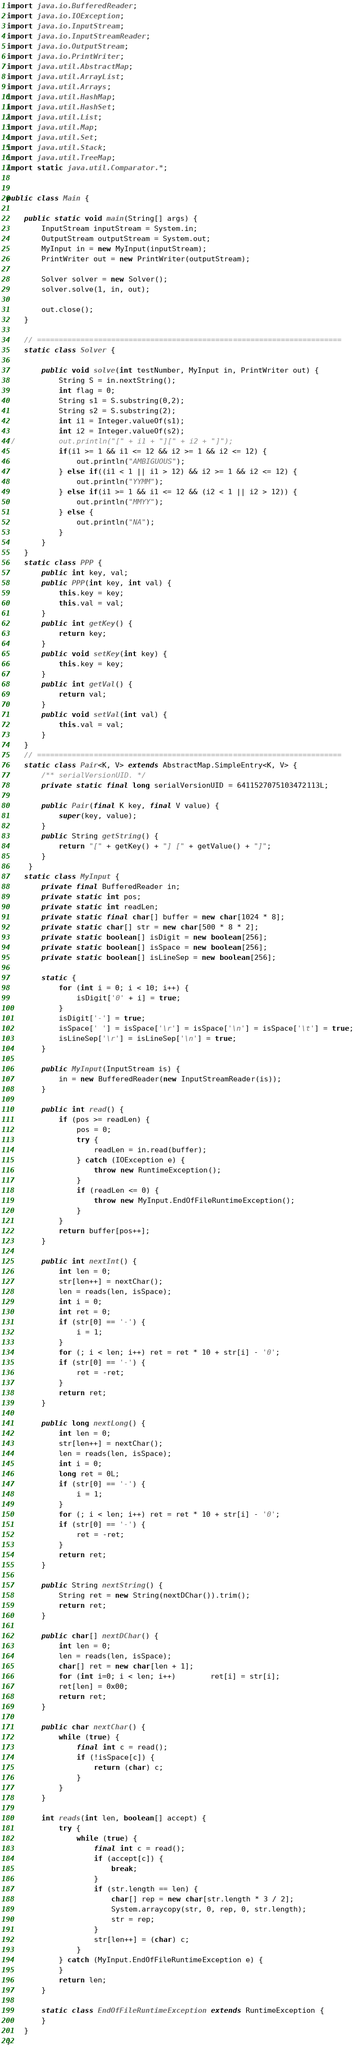Convert code to text. <code><loc_0><loc_0><loc_500><loc_500><_Java_>import java.io.BufferedReader;
import java.io.IOException;
import java.io.InputStream;
import java.io.InputStreamReader;
import java.io.OutputStream;
import java.io.PrintWriter;
import java.util.AbstractMap;
import java.util.ArrayList;
import java.util.Arrays;
import java.util.HashMap;
import java.util.HashSet;
import java.util.List;
import java.util.Map;
import java.util.Set;
import java.util.Stack;
import java.util.TreeMap;
import static java.util.Comparator.*;


public class Main {
	
	public static void main(String[] args) {
        InputStream inputStream = System.in;
        OutputStream outputStream = System.out;
        MyInput in = new MyInput(inputStream);
        PrintWriter out = new PrintWriter(outputStream);
        
        Solver solver = new Solver();
        solver.solve(1, in, out);
        
        out.close();
    }
    
    // ======================================================================
    static class Solver {

    	public void solve(int testNumber, MyInput in, PrintWriter out) {
    		String S = in.nextString();
    		int flag = 0;
    		String s1 = S.substring(0,2);
    		String s2 = S.substring(2);
    		int i1 = Integer.valueOf(s1);
    		int i2 = Integer.valueOf(s2);
//    		out.println("[" + i1 + "][" + i2 + "]");
    		if(i1 >= 1 && i1 <= 12 && i2 >= 1 && i2 <= 12) {
        		out.println("AMBIGUOUS");
    		} else if((i1 < 1 || i1 > 12) && i2 >= 1 && i2 <= 12) {
        		out.println("YYMM");
    		} else if(i1 >= 1 && i1 <= 12 && (i2 < 1 || i2 > 12)) {
        		out.println("MMYY");
    		} else {
    			out.println("NA");
    		}
        }
    }
    static class PPP {
    	public int key, val;
    	public PPP(int key, int val) {
    		this.key = key;
    		this.val = val;
    	}
		public int getKey() {
			return key;
		}
		public void setKey(int key) {
			this.key = key;
		}
		public int getVal() {
			return val;
		}
		public void setVal(int val) {
			this.val = val;
		}
    }
    // ======================================================================
    static class Pair<K, V> extends AbstractMap.SimpleEntry<K, V> {
        /** serialVersionUID. */
        private static final long serialVersionUID = 6411527075103472113L;

        public Pair(final K key, final V value) {
            super(key, value);
        }
        public String getString() {
            return "[" + getKey() + "] [" + getValue() + "]";
        }
     }    
    static class MyInput {
        private final BufferedReader in;
        private static int pos;
        private static int readLen;
        private static final char[] buffer = new char[1024 * 8];
        private static char[] str = new char[500 * 8 * 2];
        private static boolean[] isDigit = new boolean[256];
        private static boolean[] isSpace = new boolean[256];
        private static boolean[] isLineSep = new boolean[256];
 
        static {
            for (int i = 0; i < 10; i++) {
                isDigit['0' + i] = true;
            }
            isDigit['-'] = true;
            isSpace[' '] = isSpace['\r'] = isSpace['\n'] = isSpace['\t'] = true;
            isLineSep['\r'] = isLineSep['\n'] = true;
        }
 
        public MyInput(InputStream is) {
            in = new BufferedReader(new InputStreamReader(is));
        }
 
        public int read() {
            if (pos >= readLen) {
                pos = 0;
                try {
                    readLen = in.read(buffer);
                } catch (IOException e) {
                    throw new RuntimeException();
                }
                if (readLen <= 0) {
                    throw new MyInput.EndOfFileRuntimeException();
                }
            }
            return buffer[pos++];
        }
 
        public int nextInt() {
            int len = 0;
            str[len++] = nextChar();
            len = reads(len, isSpace);
            int i = 0;
            int ret = 0;
            if (str[0] == '-') {
                i = 1;
            }
            for (; i < len; i++) ret = ret * 10 + str[i] - '0';
            if (str[0] == '-') {
                ret = -ret;
            }
            return ret;
        }
 
        public long nextLong() {
            int len = 0;
            str[len++] = nextChar();
            len = reads(len, isSpace);
            int i = 0;
            long ret = 0L;
            if (str[0] == '-') {
                i = 1;
            }
            for (; i < len; i++) ret = ret * 10 + str[i] - '0';
            if (str[0] == '-') {
                ret = -ret;
            }
            return ret;
        }
 
        public String nextString() {
        	String ret = new String(nextDChar()).trim();
            return ret;
        }
 
        public char[] nextDChar() {
            int len = 0;
            len = reads(len, isSpace);
            char[] ret = new char[len + 1];
            for (int i=0; i < len; i++)		ret[i] = str[i];
            ret[len] = 0x00;
            return ret;
        }
 
        public char nextChar() {
            while (true) {
                final int c = read();
                if (!isSpace[c]) {
                    return (char) c;
                }
            }
        }
 
        int reads(int len, boolean[] accept) {
            try {
                while (true) {
                    final int c = read();
                    if (accept[c]) {
                        break;
                    }
                    if (str.length == len) {
                        char[] rep = new char[str.length * 3 / 2];
                        System.arraycopy(str, 0, rep, 0, str.length);
                        str = rep;
                    }
                    str[len++] = (char) c;
                }
            } catch (MyInput.EndOfFileRuntimeException e) {
            }
            return len;
        }
 
        static class EndOfFileRuntimeException extends RuntimeException {
        }
    }
}
</code> 